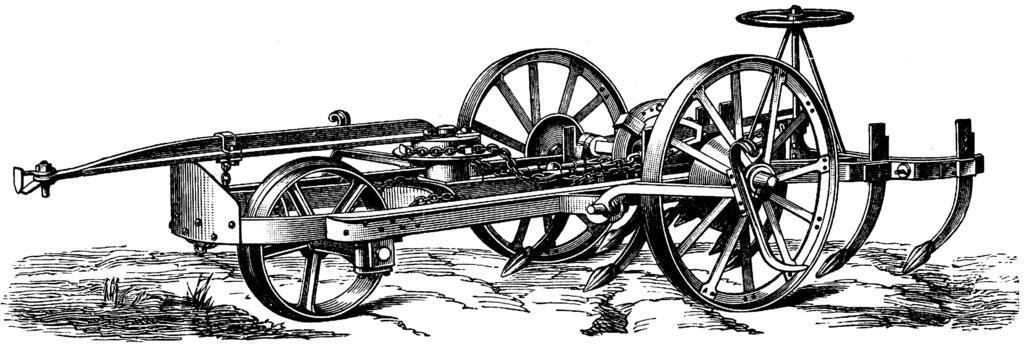Can you describe this image briefly? This image is a painting. In this we can see a cart. 